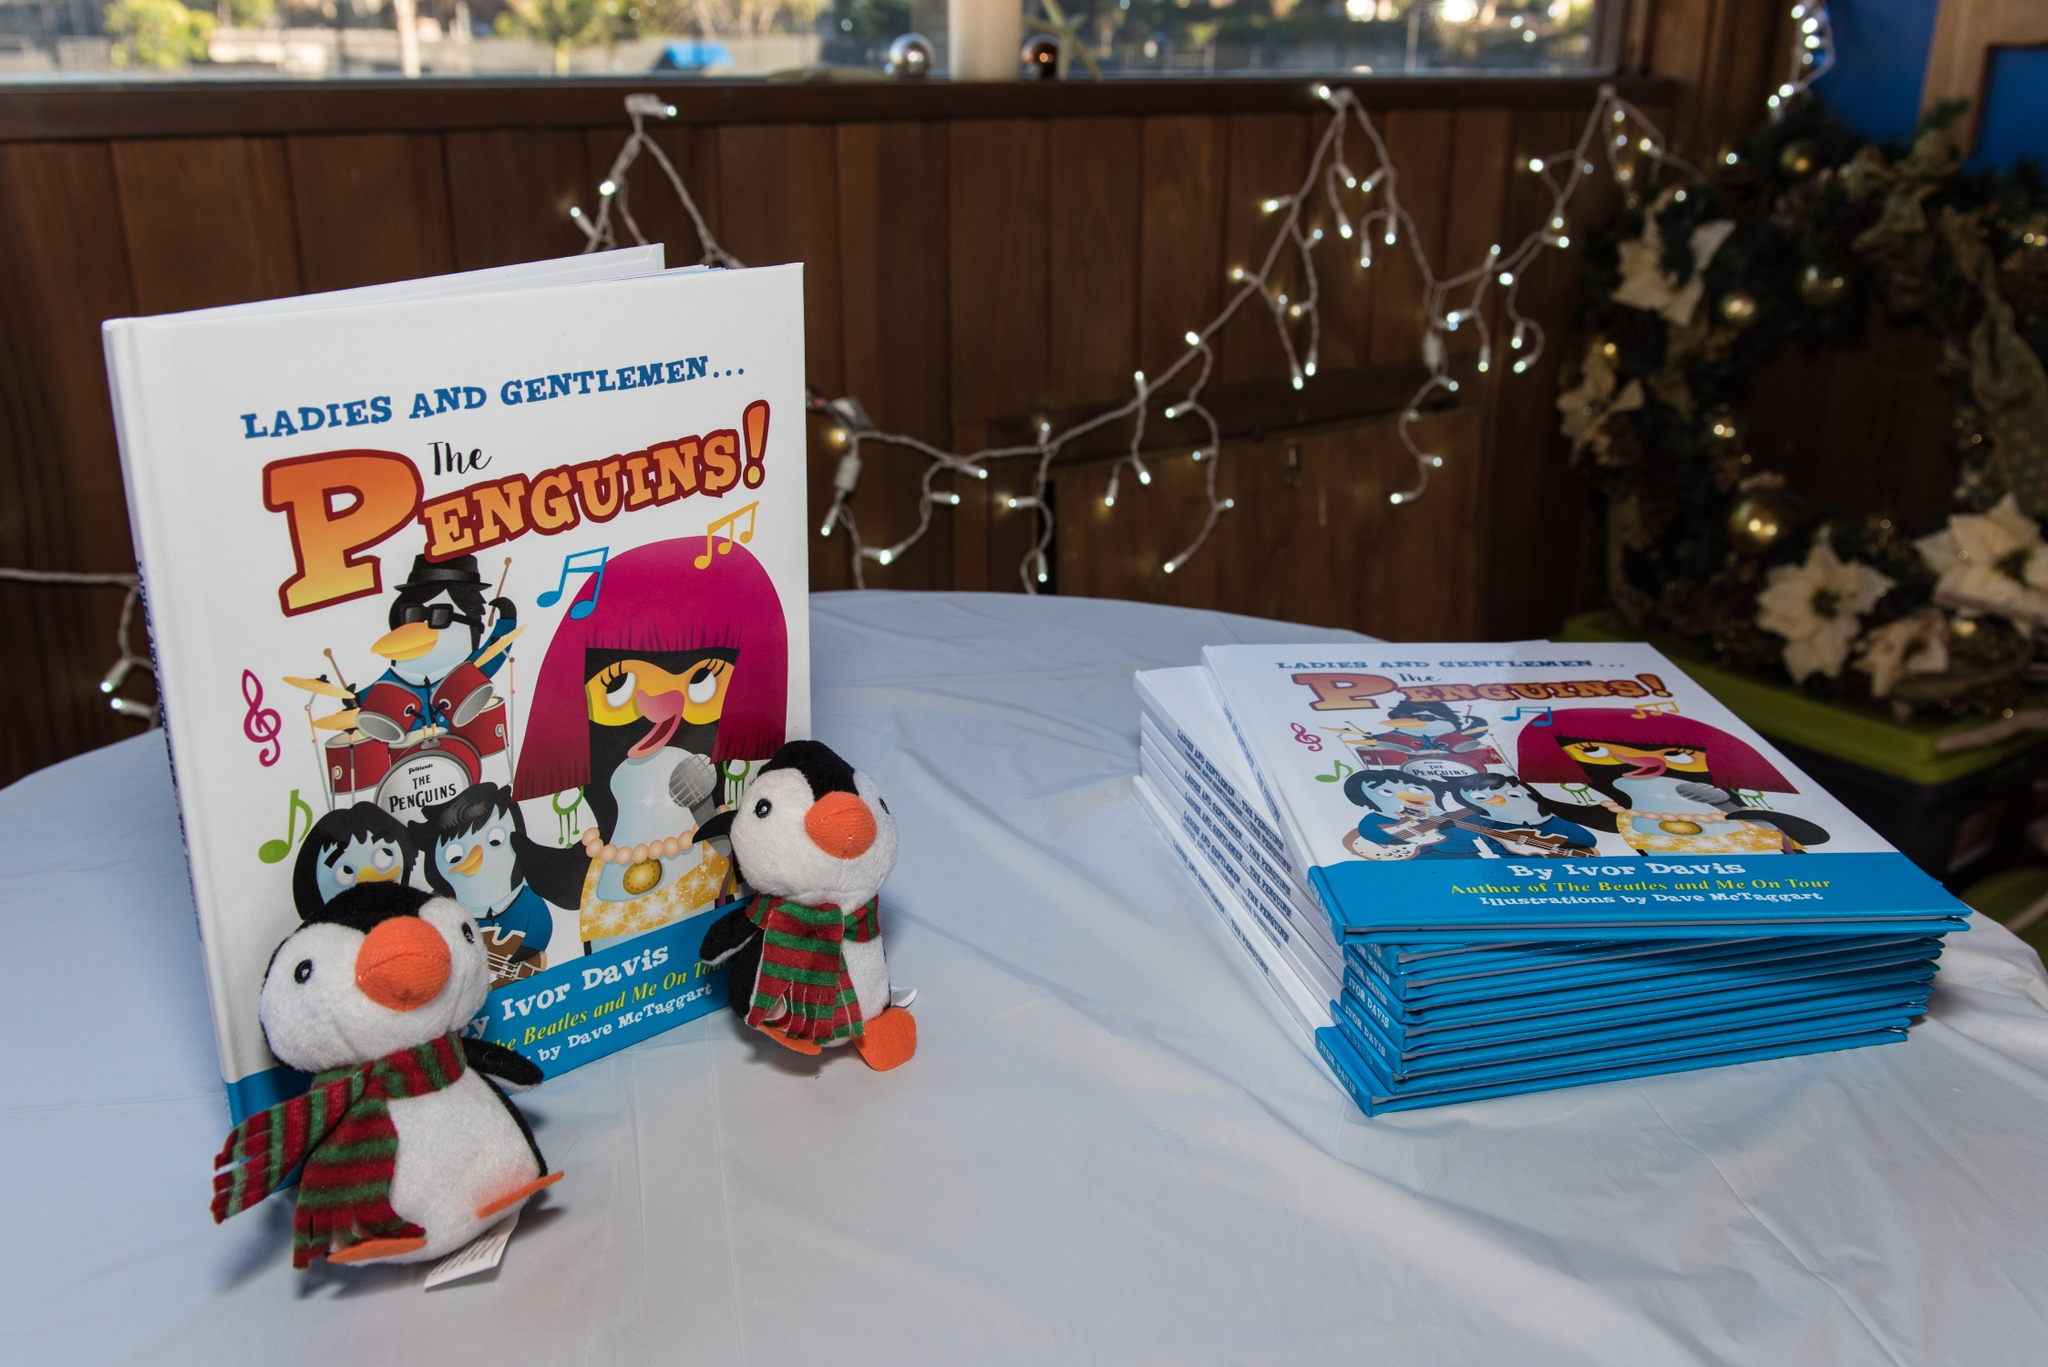Can you tell me more about the setting where the books are displayed? Certainly! The books are arranged on a white tablecloth, which gives a clean and professional look to the display. Also noticeable in the background are holiday string lights draped along a wooden panel, which adds a cozy and festive atmosphere to the setting. This arrangement typically suggests the event might be indoors, possibly in a bookshop, library, or community center. What gives this image a holiday vibe? There are several elements that contribute to the holiday vibe of the image. Firstly, the presence of string lights often associated with festive decorations clues us into a holiday theme. Secondly, the penguin plush toys are adorned with holiday accessories—one with a scarf and the other in a holiday-themed dress, which are commonly worn during festive seasons. Together, these details create a visual impression that aligns with common holiday or Christmas aesthetics. 